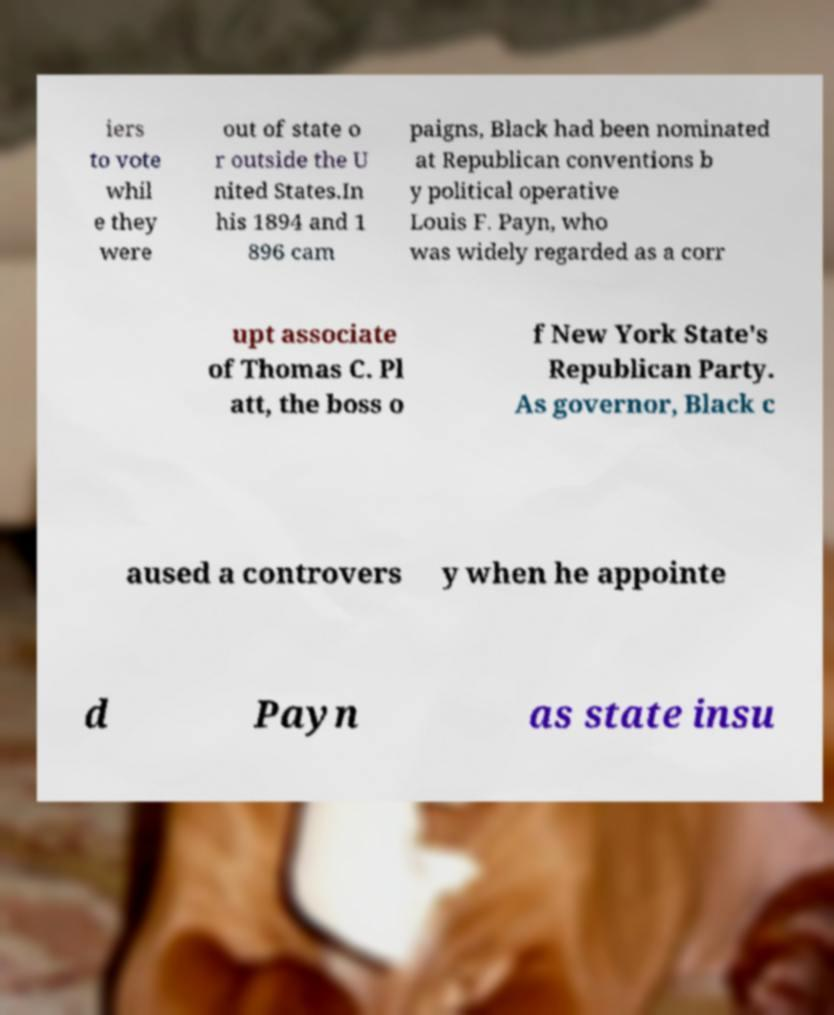Please identify and transcribe the text found in this image. iers to vote whil e they were out of state o r outside the U nited States.In his 1894 and 1 896 cam paigns, Black had been nominated at Republican conventions b y political operative Louis F. Payn, who was widely regarded as a corr upt associate of Thomas C. Pl att, the boss o f New York State's Republican Party. As governor, Black c aused a controvers y when he appointe d Payn as state insu 